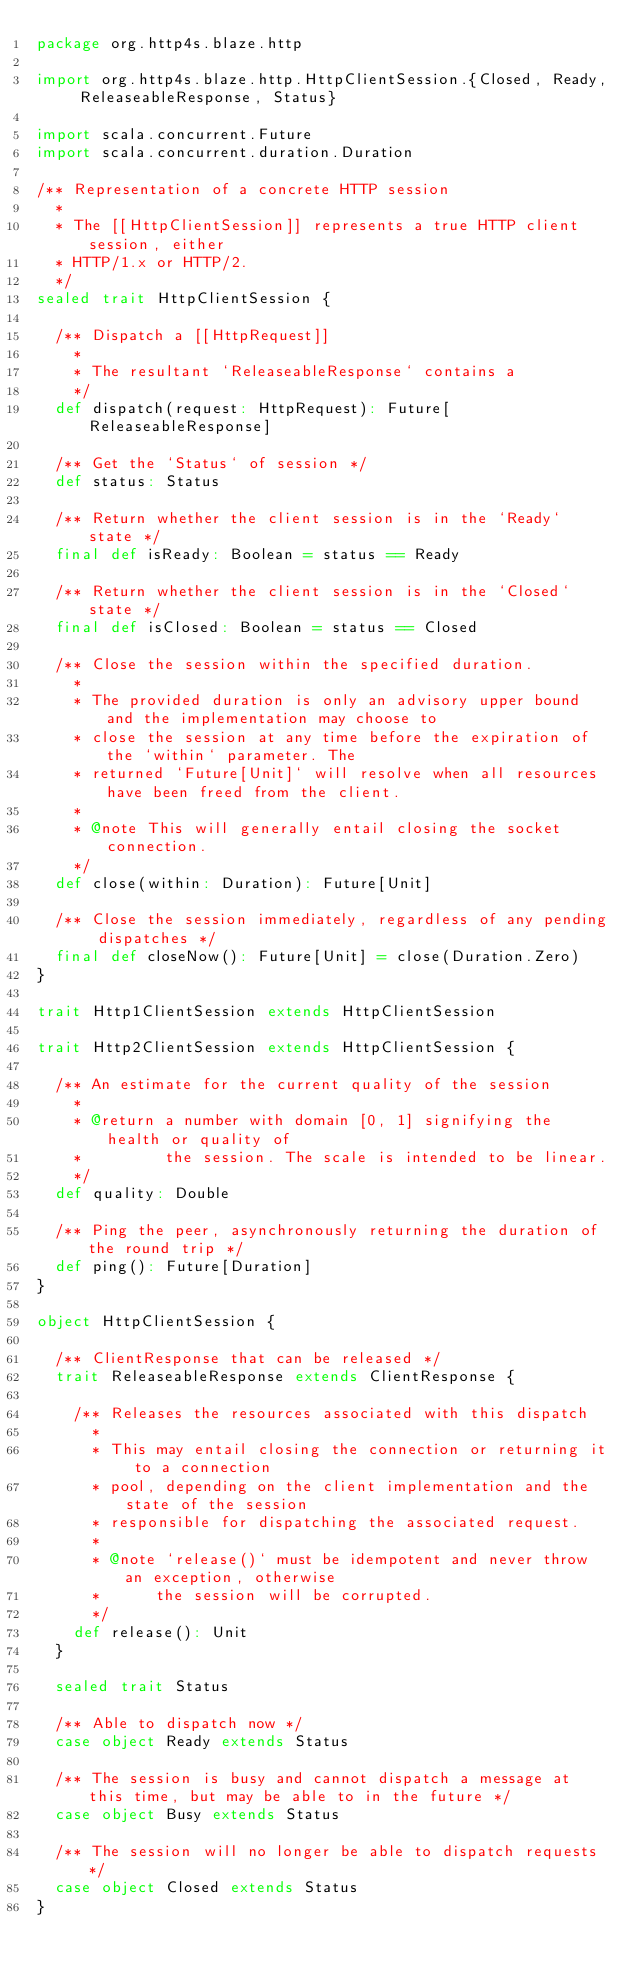<code> <loc_0><loc_0><loc_500><loc_500><_Scala_>package org.http4s.blaze.http

import org.http4s.blaze.http.HttpClientSession.{Closed, Ready, ReleaseableResponse, Status}

import scala.concurrent.Future
import scala.concurrent.duration.Duration

/** Representation of a concrete HTTP session
  *
  * The [[HttpClientSession]] represents a true HTTP client session, either
  * HTTP/1.x or HTTP/2.
  */
sealed trait HttpClientSession {

  /** Dispatch a [[HttpRequest]]
    *
    * The resultant `ReleaseableResponse` contains a
    */
  def dispatch(request: HttpRequest): Future[ReleaseableResponse]

  /** Get the `Status` of session */
  def status: Status

  /** Return whether the client session is in the `Ready` state */
  final def isReady: Boolean = status == Ready

  /** Return whether the client session is in the `Closed` state */
  final def isClosed: Boolean = status == Closed

  /** Close the session within the specified duration.
    *
    * The provided duration is only an advisory upper bound and the implementation may choose to
    * close the session at any time before the expiration of the `within` parameter. The
    * returned `Future[Unit]` will resolve when all resources have been freed from the client.
    *
    * @note This will generally entail closing the socket connection.
    */
  def close(within: Duration): Future[Unit]

  /** Close the session immediately, regardless of any pending dispatches */
  final def closeNow(): Future[Unit] = close(Duration.Zero)
}

trait Http1ClientSession extends HttpClientSession

trait Http2ClientSession extends HttpClientSession {

  /** An estimate for the current quality of the session
    *
    * @return a number with domain [0, 1] signifying the health or quality of
    *         the session. The scale is intended to be linear.
    */
  def quality: Double

  /** Ping the peer, asynchronously returning the duration of the round trip */
  def ping(): Future[Duration]
}

object HttpClientSession {

  /** ClientResponse that can be released */
  trait ReleaseableResponse extends ClientResponse {

    /** Releases the resources associated with this dispatch
      *
      * This may entail closing the connection or returning it to a connection
      * pool, depending on the client implementation and the state of the session
      * responsible for dispatching the associated request.
      *
      * @note `release()` must be idempotent and never throw an exception, otherwise
      *      the session will be corrupted.
      */
    def release(): Unit
  }

  sealed trait Status

  /** Able to dispatch now */
  case object Ready extends Status

  /** The session is busy and cannot dispatch a message at this time, but may be able to in the future */
  case object Busy extends Status

  /** The session will no longer be able to dispatch requests */
  case object Closed extends Status
}
</code> 